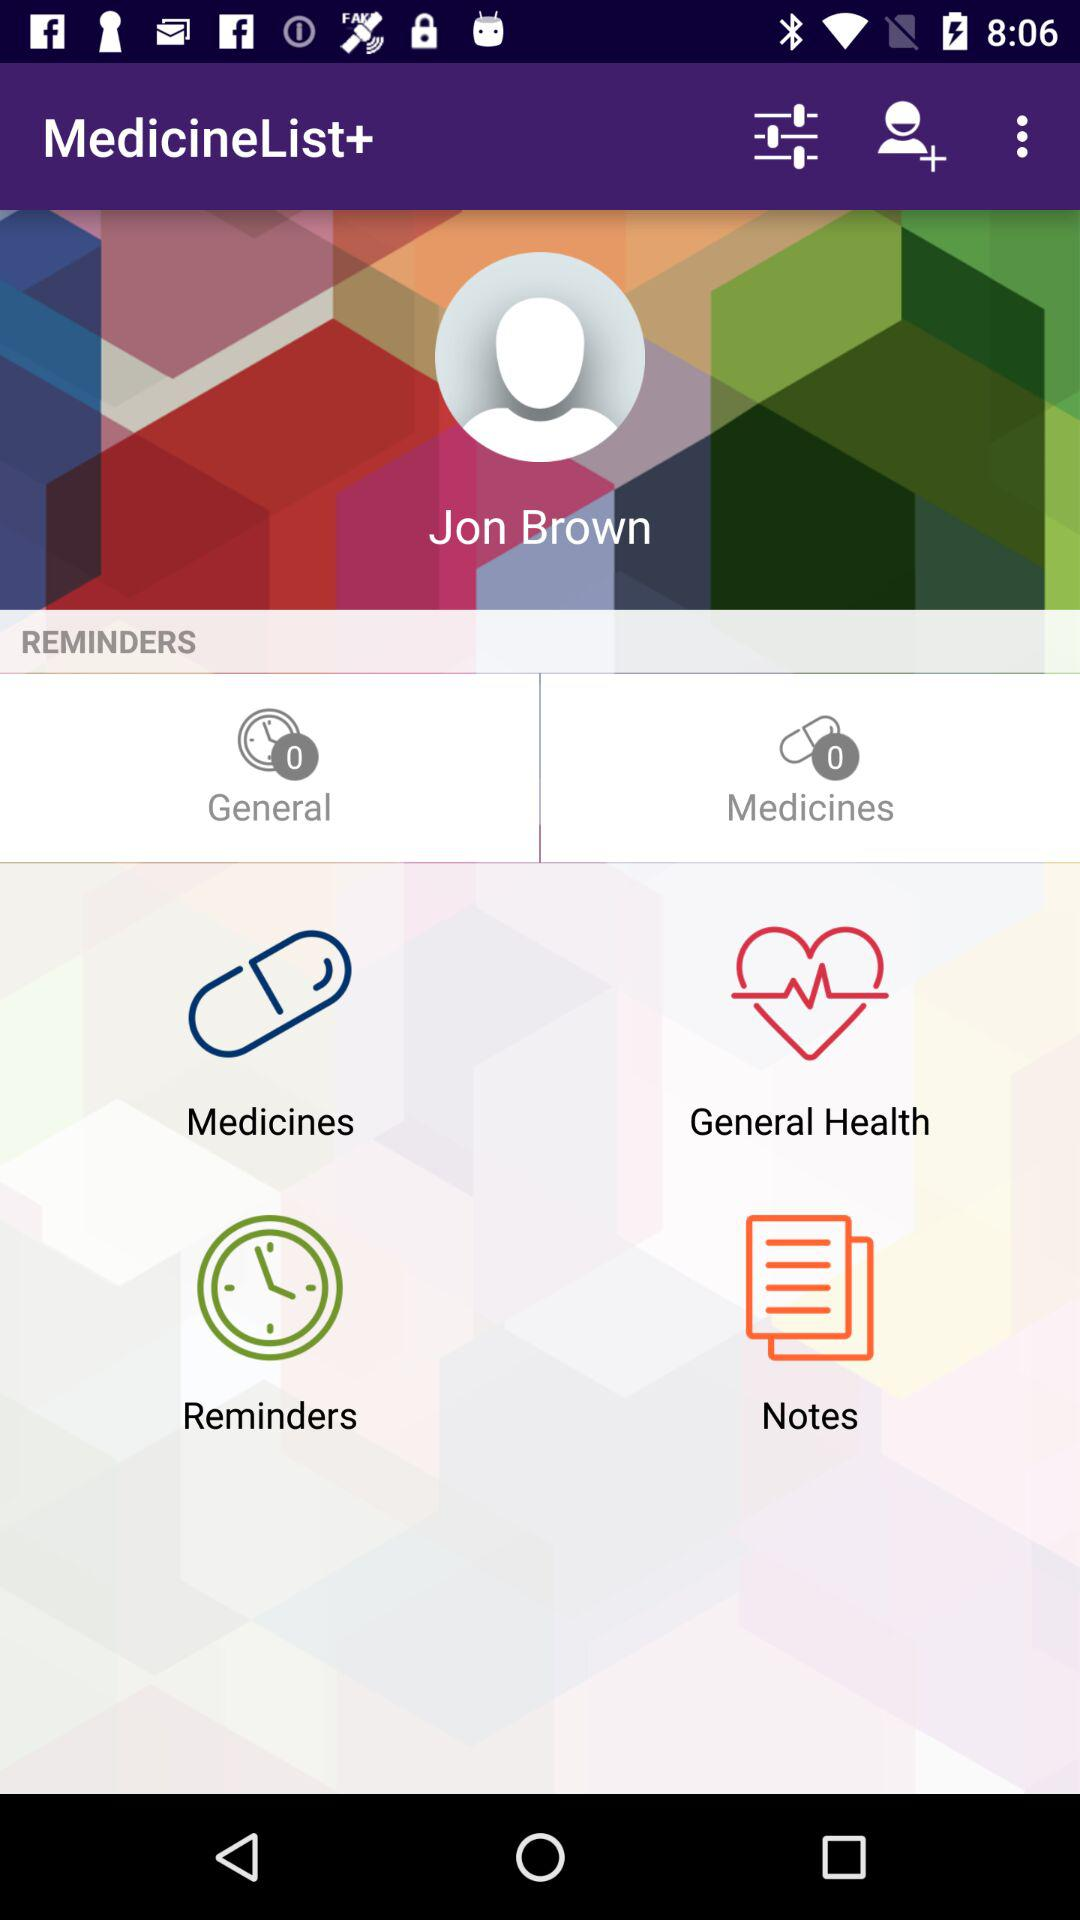What is the count for medicines? The count is 0. 